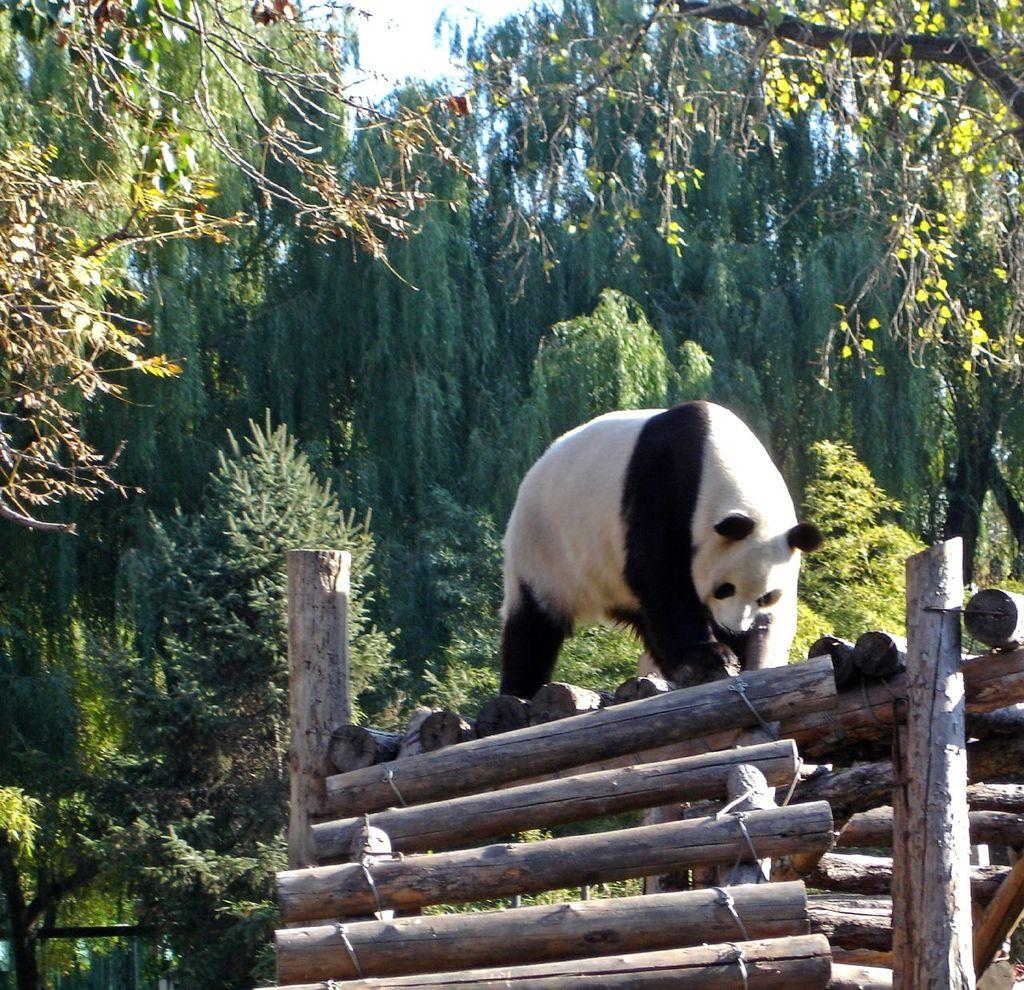Where was the picture taken? The picture was clicked outside the city. What can be seen in the foreground of the image? There are wooden bamboos in the foreground. What is the main subject of the image? There is a panda in the center of the image. What can be seen in the background of the image? The sky, trees, and plants are visible in the background. How many beginner-level buildings are visible in the image? There are no buildings present in the image, let alone beginner-level ones. What type of servant can be seen attending to the panda in the image? There are no servants present in the image; the panda is the main subject. 